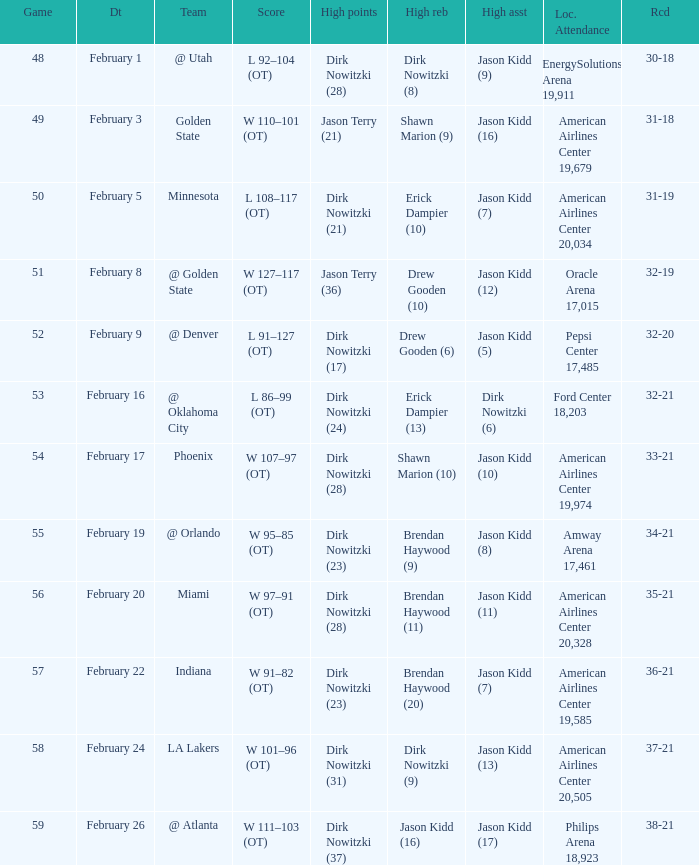Who had the most high assists with a record of 32-19? Jason Kidd (12). 